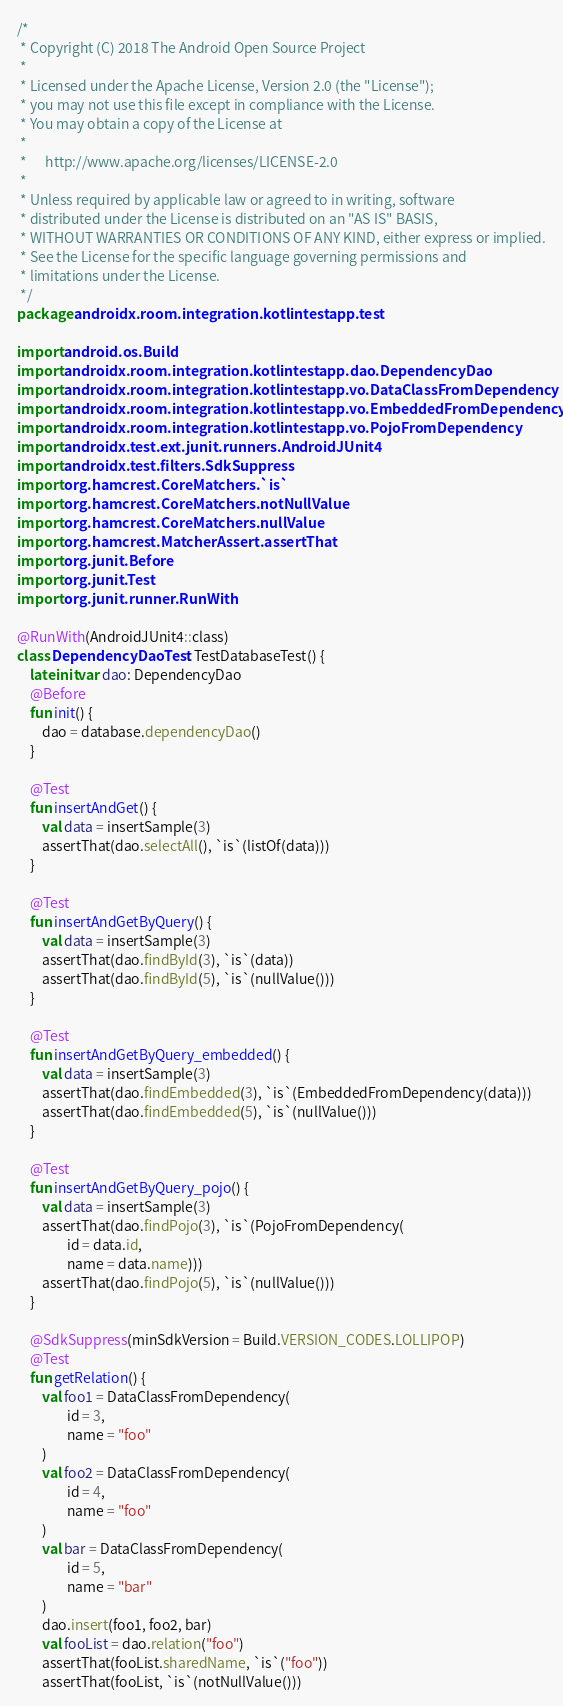<code> <loc_0><loc_0><loc_500><loc_500><_Kotlin_>/*
 * Copyright (C) 2018 The Android Open Source Project
 *
 * Licensed under the Apache License, Version 2.0 (the "License");
 * you may not use this file except in compliance with the License.
 * You may obtain a copy of the License at
 *
 *      http://www.apache.org/licenses/LICENSE-2.0
 *
 * Unless required by applicable law or agreed to in writing, software
 * distributed under the License is distributed on an "AS IS" BASIS,
 * WITHOUT WARRANTIES OR CONDITIONS OF ANY KIND, either express or implied.
 * See the License for the specific language governing permissions and
 * limitations under the License.
 */
package androidx.room.integration.kotlintestapp.test

import android.os.Build
import androidx.room.integration.kotlintestapp.dao.DependencyDao
import androidx.room.integration.kotlintestapp.vo.DataClassFromDependency
import androidx.room.integration.kotlintestapp.vo.EmbeddedFromDependency
import androidx.room.integration.kotlintestapp.vo.PojoFromDependency
import androidx.test.ext.junit.runners.AndroidJUnit4
import androidx.test.filters.SdkSuppress
import org.hamcrest.CoreMatchers.`is`
import org.hamcrest.CoreMatchers.notNullValue
import org.hamcrest.CoreMatchers.nullValue
import org.hamcrest.MatcherAssert.assertThat
import org.junit.Before
import org.junit.Test
import org.junit.runner.RunWith

@RunWith(AndroidJUnit4::class)
class DependencyDaoTest : TestDatabaseTest() {
    lateinit var dao: DependencyDao
    @Before
    fun init() {
        dao = database.dependencyDao()
    }

    @Test
    fun insertAndGet() {
        val data = insertSample(3)
        assertThat(dao.selectAll(), `is`(listOf(data)))
    }

    @Test
    fun insertAndGetByQuery() {
        val data = insertSample(3)
        assertThat(dao.findById(3), `is`(data))
        assertThat(dao.findById(5), `is`(nullValue()))
    }

    @Test
    fun insertAndGetByQuery_embedded() {
        val data = insertSample(3)
        assertThat(dao.findEmbedded(3), `is`(EmbeddedFromDependency(data)))
        assertThat(dao.findEmbedded(5), `is`(nullValue()))
    }

    @Test
    fun insertAndGetByQuery_pojo() {
        val data = insertSample(3)
        assertThat(dao.findPojo(3), `is`(PojoFromDependency(
                id = data.id,
                name = data.name)))
        assertThat(dao.findPojo(5), `is`(nullValue()))
    }

    @SdkSuppress(minSdkVersion = Build.VERSION_CODES.LOLLIPOP)
    @Test
    fun getRelation() {
        val foo1 = DataClassFromDependency(
                id = 3,
                name = "foo"
        )
        val foo2 = DataClassFromDependency(
                id = 4,
                name = "foo"
        )
        val bar = DataClassFromDependency(
                id = 5,
                name = "bar"
        )
        dao.insert(foo1, foo2, bar)
        val fooList = dao.relation("foo")
        assertThat(fooList.sharedName, `is`("foo"))
        assertThat(fooList, `is`(notNullValue()))</code> 